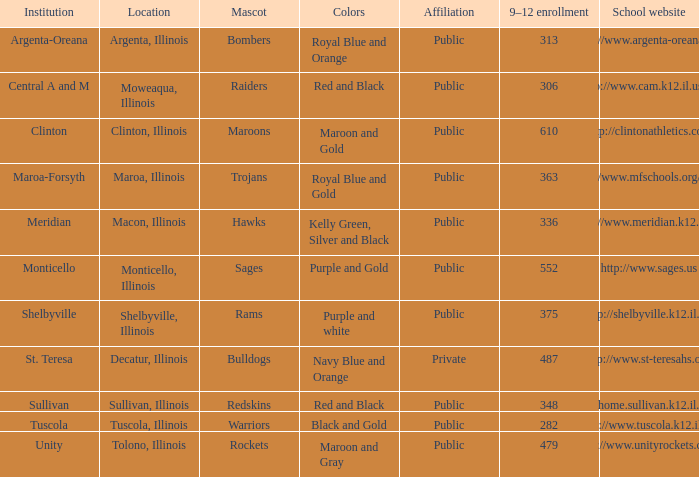What are the team colors from Tolono, Illinois? Maroon and Gray. Can you give me this table as a dict? {'header': ['Institution', 'Location', 'Mascot', 'Colors', 'Affiliation', '9–12 enrollment', 'School website'], 'rows': [['Argenta-Oreana', 'Argenta, Illinois', 'Bombers', 'Royal Blue and Orange', 'Public', '313', 'http://www.argenta-oreana.org'], ['Central A and M', 'Moweaqua, Illinois', 'Raiders', 'Red and Black', 'Public', '306', 'http://www.cam.k12.il.us/hs'], ['Clinton', 'Clinton, Illinois', 'Maroons', 'Maroon and Gold', 'Public', '610', 'http://clintonathletics.com'], ['Maroa-Forsyth', 'Maroa, Illinois', 'Trojans', 'Royal Blue and Gold', 'Public', '363', 'http://www.mfschools.org/high/'], ['Meridian', 'Macon, Illinois', 'Hawks', 'Kelly Green, Silver and Black', 'Public', '336', 'http://www.meridian.k12.il.us/'], ['Monticello', 'Monticello, Illinois', 'Sages', 'Purple and Gold', 'Public', '552', 'http://www.sages.us'], ['Shelbyville', 'Shelbyville, Illinois', 'Rams', 'Purple and white', 'Public', '375', 'http://shelbyville.k12.il.us/'], ['St. Teresa', 'Decatur, Illinois', 'Bulldogs', 'Navy Blue and Orange', 'Private', '487', 'http://www.st-teresahs.org/'], ['Sullivan', 'Sullivan, Illinois', 'Redskins', 'Red and Black', 'Public', '348', 'http://home.sullivan.k12.il.us/shs'], ['Tuscola', 'Tuscola, Illinois', 'Warriors', 'Black and Gold', 'Public', '282', 'http://www.tuscola.k12.il.us/'], ['Unity', 'Tolono, Illinois', 'Rockets', 'Maroon and Gray', 'Public', '479', 'http://www.unityrockets.com/']]} 